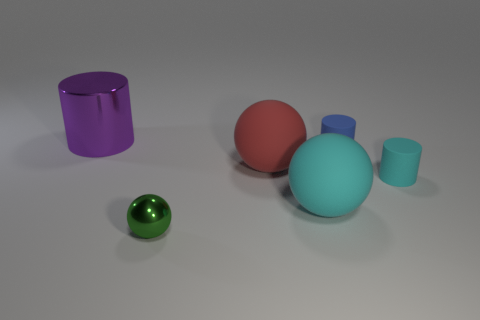Subtract all red rubber spheres. How many spheres are left? 2 Add 2 metallic balls. How many objects exist? 8 Subtract 1 balls. How many balls are left? 2 Subtract all brown cylinders. Subtract all purple spheres. How many cylinders are left? 3 Subtract all big cyan metallic cylinders. Subtract all tiny blue cylinders. How many objects are left? 5 Add 5 large cylinders. How many large cylinders are left? 6 Add 1 red matte things. How many red matte things exist? 2 Subtract 0 yellow cubes. How many objects are left? 6 